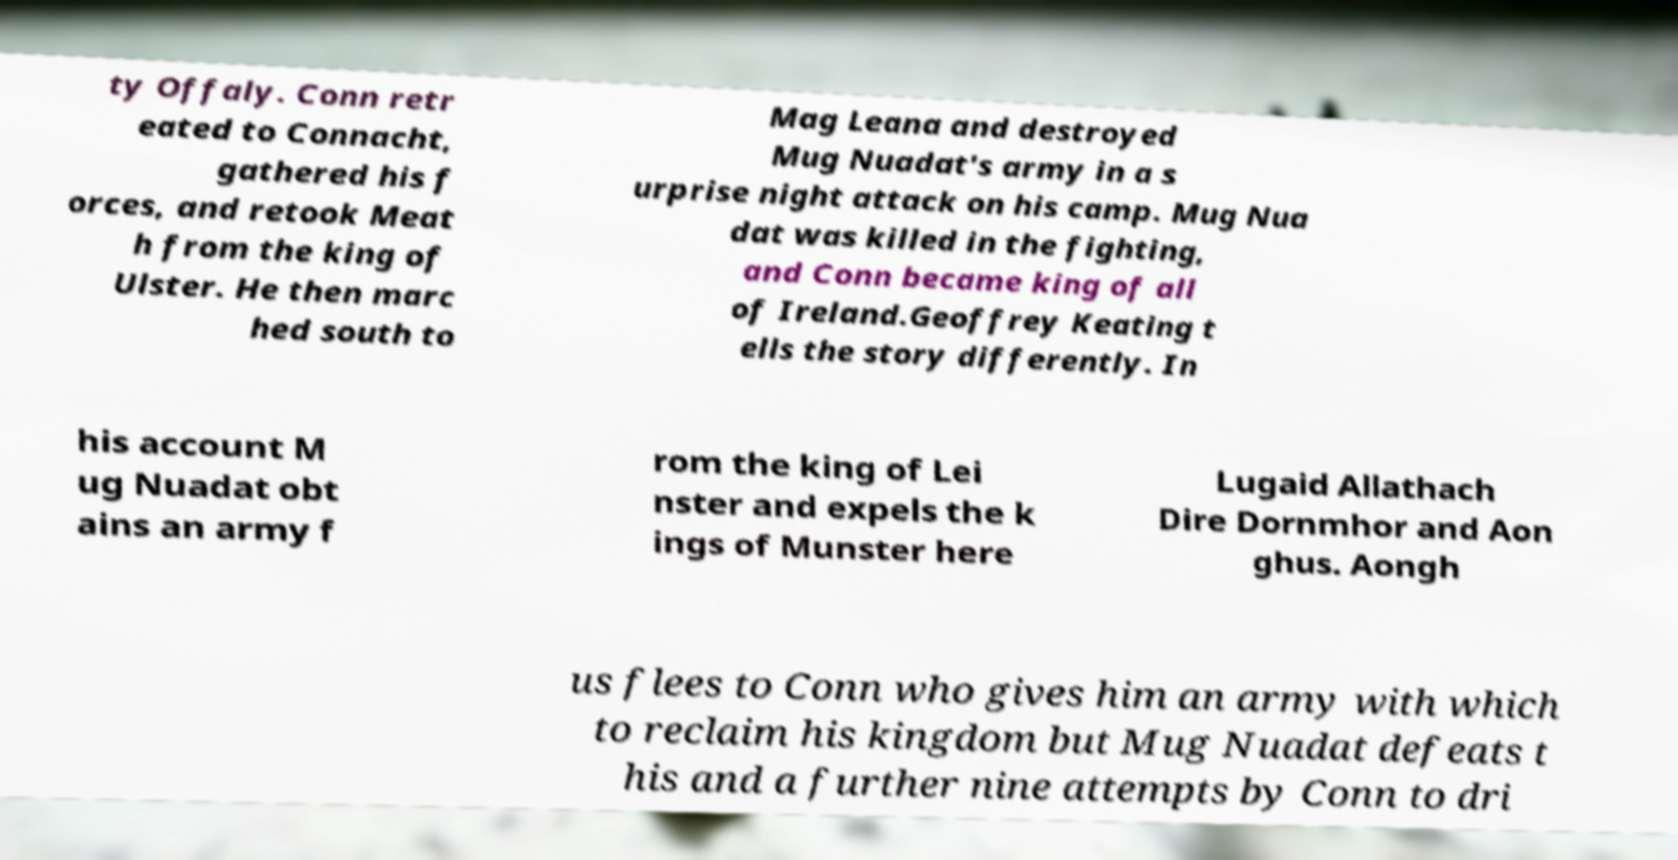I need the written content from this picture converted into text. Can you do that? ty Offaly. Conn retr eated to Connacht, gathered his f orces, and retook Meat h from the king of Ulster. He then marc hed south to Mag Leana and destroyed Mug Nuadat's army in a s urprise night attack on his camp. Mug Nua dat was killed in the fighting, and Conn became king of all of Ireland.Geoffrey Keating t ells the story differently. In his account M ug Nuadat obt ains an army f rom the king of Lei nster and expels the k ings of Munster here Lugaid Allathach Dire Dornmhor and Aon ghus. Aongh us flees to Conn who gives him an army with which to reclaim his kingdom but Mug Nuadat defeats t his and a further nine attempts by Conn to dri 